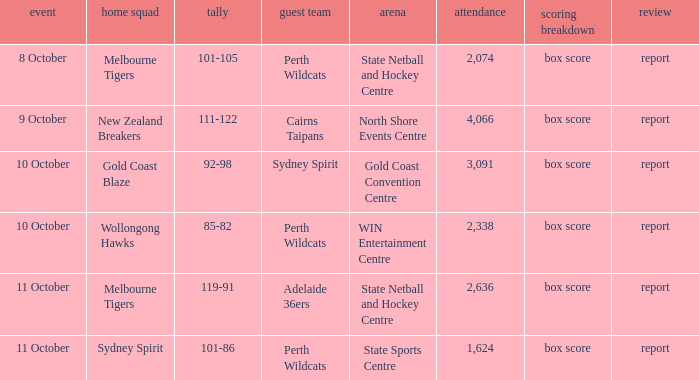What was the number of the crowd when the Wollongong Hawks were the home team? 2338.0. 